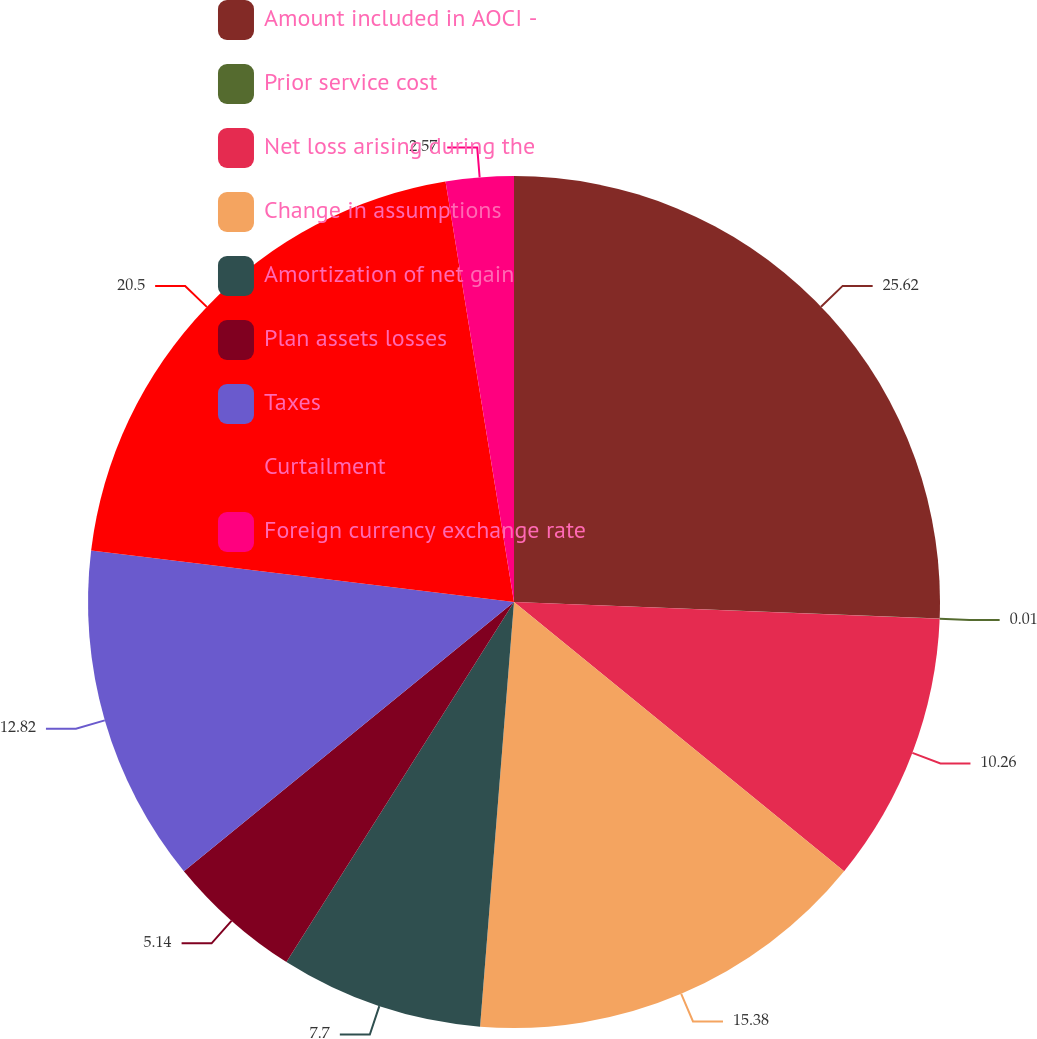<chart> <loc_0><loc_0><loc_500><loc_500><pie_chart><fcel>Amount included in AOCI -<fcel>Prior service cost<fcel>Net loss arising during the<fcel>Change in assumptions<fcel>Amortization of net gain<fcel>Plan assets losses<fcel>Taxes<fcel>Curtailment<fcel>Foreign currency exchange rate<nl><fcel>25.62%<fcel>0.01%<fcel>10.26%<fcel>15.38%<fcel>7.7%<fcel>5.14%<fcel>12.82%<fcel>20.5%<fcel>2.57%<nl></chart> 